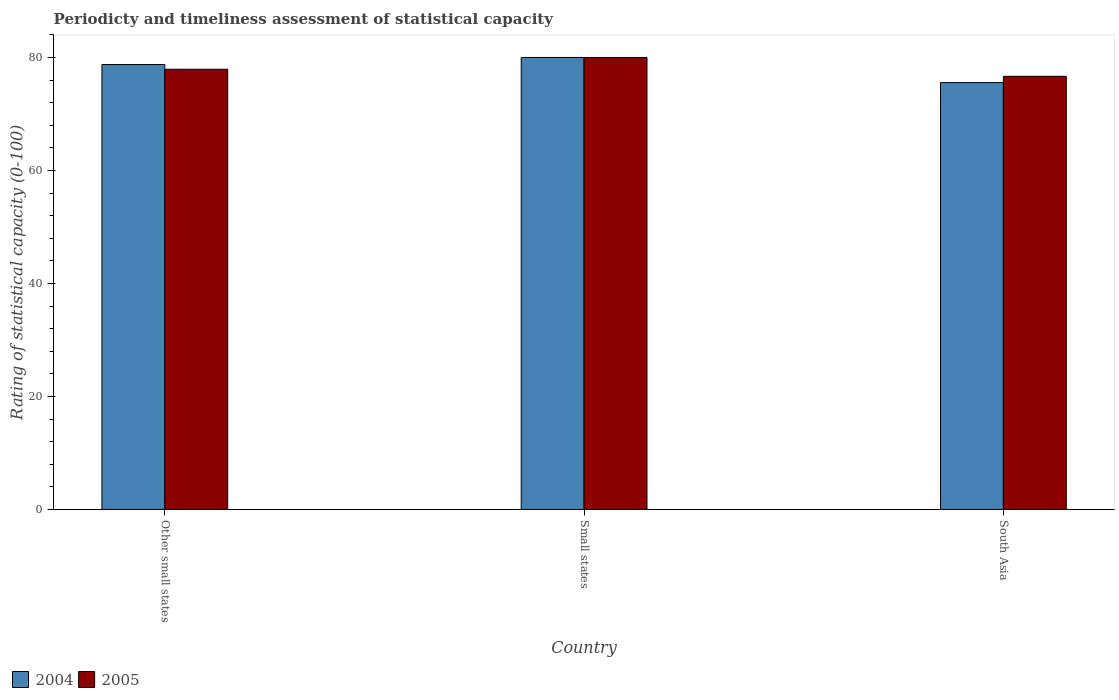How many different coloured bars are there?
Provide a short and direct response. 2. How many bars are there on the 3rd tick from the right?
Provide a succinct answer. 2. What is the label of the 2nd group of bars from the left?
Your answer should be very brief. Small states. What is the rating of statistical capacity in 2005 in Other small states?
Ensure brevity in your answer.  77.92. Across all countries, what is the maximum rating of statistical capacity in 2005?
Provide a short and direct response. 80. Across all countries, what is the minimum rating of statistical capacity in 2005?
Your answer should be compact. 76.67. In which country was the rating of statistical capacity in 2005 maximum?
Provide a short and direct response. Small states. What is the total rating of statistical capacity in 2004 in the graph?
Give a very brief answer. 234.31. What is the difference between the rating of statistical capacity in 2005 in Other small states and that in South Asia?
Offer a very short reply. 1.25. What is the difference between the rating of statistical capacity in 2004 in South Asia and the rating of statistical capacity in 2005 in Small states?
Provide a succinct answer. -4.44. What is the average rating of statistical capacity in 2004 per country?
Provide a short and direct response. 78.1. What is the difference between the rating of statistical capacity of/in 2005 and rating of statistical capacity of/in 2004 in Small states?
Ensure brevity in your answer.  -9.999999974752427e-7. What is the ratio of the rating of statistical capacity in 2005 in Small states to that in South Asia?
Your answer should be compact. 1.04. Is the rating of statistical capacity in 2005 in Small states less than that in South Asia?
Offer a very short reply. No. Is the difference between the rating of statistical capacity in 2005 in Other small states and South Asia greater than the difference between the rating of statistical capacity in 2004 in Other small states and South Asia?
Offer a very short reply. No. What is the difference between the highest and the second highest rating of statistical capacity in 2004?
Ensure brevity in your answer.  4.44. What is the difference between the highest and the lowest rating of statistical capacity in 2005?
Provide a succinct answer. 3.33. What does the 1st bar from the right in Small states represents?
Your response must be concise. 2005. Are all the bars in the graph horizontal?
Provide a succinct answer. No. Does the graph contain grids?
Your answer should be compact. No. How are the legend labels stacked?
Keep it short and to the point. Horizontal. What is the title of the graph?
Give a very brief answer. Periodicty and timeliness assessment of statistical capacity. Does "1982" appear as one of the legend labels in the graph?
Make the answer very short. No. What is the label or title of the Y-axis?
Provide a succinct answer. Rating of statistical capacity (0-100). What is the Rating of statistical capacity (0-100) in 2004 in Other small states?
Your response must be concise. 78.75. What is the Rating of statistical capacity (0-100) of 2005 in Other small states?
Provide a short and direct response. 77.92. What is the Rating of statistical capacity (0-100) in 2004 in Small states?
Provide a short and direct response. 80. What is the Rating of statistical capacity (0-100) in 2005 in Small states?
Provide a succinct answer. 80. What is the Rating of statistical capacity (0-100) of 2004 in South Asia?
Make the answer very short. 75.56. What is the Rating of statistical capacity (0-100) of 2005 in South Asia?
Offer a terse response. 76.67. Across all countries, what is the maximum Rating of statistical capacity (0-100) in 2005?
Your answer should be compact. 80. Across all countries, what is the minimum Rating of statistical capacity (0-100) of 2004?
Ensure brevity in your answer.  75.56. Across all countries, what is the minimum Rating of statistical capacity (0-100) of 2005?
Your response must be concise. 76.67. What is the total Rating of statistical capacity (0-100) in 2004 in the graph?
Ensure brevity in your answer.  234.31. What is the total Rating of statistical capacity (0-100) in 2005 in the graph?
Your response must be concise. 234.58. What is the difference between the Rating of statistical capacity (0-100) of 2004 in Other small states and that in Small states?
Make the answer very short. -1.25. What is the difference between the Rating of statistical capacity (0-100) in 2005 in Other small states and that in Small states?
Provide a short and direct response. -2.08. What is the difference between the Rating of statistical capacity (0-100) in 2004 in Other small states and that in South Asia?
Your answer should be compact. 3.19. What is the difference between the Rating of statistical capacity (0-100) in 2005 in Other small states and that in South Asia?
Provide a succinct answer. 1.25. What is the difference between the Rating of statistical capacity (0-100) of 2004 in Small states and that in South Asia?
Offer a terse response. 4.44. What is the difference between the Rating of statistical capacity (0-100) of 2004 in Other small states and the Rating of statistical capacity (0-100) of 2005 in Small states?
Your response must be concise. -1.25. What is the difference between the Rating of statistical capacity (0-100) of 2004 in Other small states and the Rating of statistical capacity (0-100) of 2005 in South Asia?
Give a very brief answer. 2.08. What is the difference between the Rating of statistical capacity (0-100) of 2004 in Small states and the Rating of statistical capacity (0-100) of 2005 in South Asia?
Ensure brevity in your answer.  3.33. What is the average Rating of statistical capacity (0-100) of 2004 per country?
Provide a succinct answer. 78.1. What is the average Rating of statistical capacity (0-100) in 2005 per country?
Ensure brevity in your answer.  78.19. What is the difference between the Rating of statistical capacity (0-100) of 2004 and Rating of statistical capacity (0-100) of 2005 in Other small states?
Provide a succinct answer. 0.83. What is the difference between the Rating of statistical capacity (0-100) of 2004 and Rating of statistical capacity (0-100) of 2005 in South Asia?
Provide a succinct answer. -1.11. What is the ratio of the Rating of statistical capacity (0-100) in 2004 in Other small states to that in Small states?
Your answer should be very brief. 0.98. What is the ratio of the Rating of statistical capacity (0-100) in 2005 in Other small states to that in Small states?
Offer a terse response. 0.97. What is the ratio of the Rating of statistical capacity (0-100) of 2004 in Other small states to that in South Asia?
Give a very brief answer. 1.04. What is the ratio of the Rating of statistical capacity (0-100) in 2005 in Other small states to that in South Asia?
Provide a short and direct response. 1.02. What is the ratio of the Rating of statistical capacity (0-100) in 2004 in Small states to that in South Asia?
Make the answer very short. 1.06. What is the ratio of the Rating of statistical capacity (0-100) in 2005 in Small states to that in South Asia?
Provide a short and direct response. 1.04. What is the difference between the highest and the second highest Rating of statistical capacity (0-100) in 2005?
Your answer should be very brief. 2.08. What is the difference between the highest and the lowest Rating of statistical capacity (0-100) of 2004?
Your answer should be compact. 4.44. 